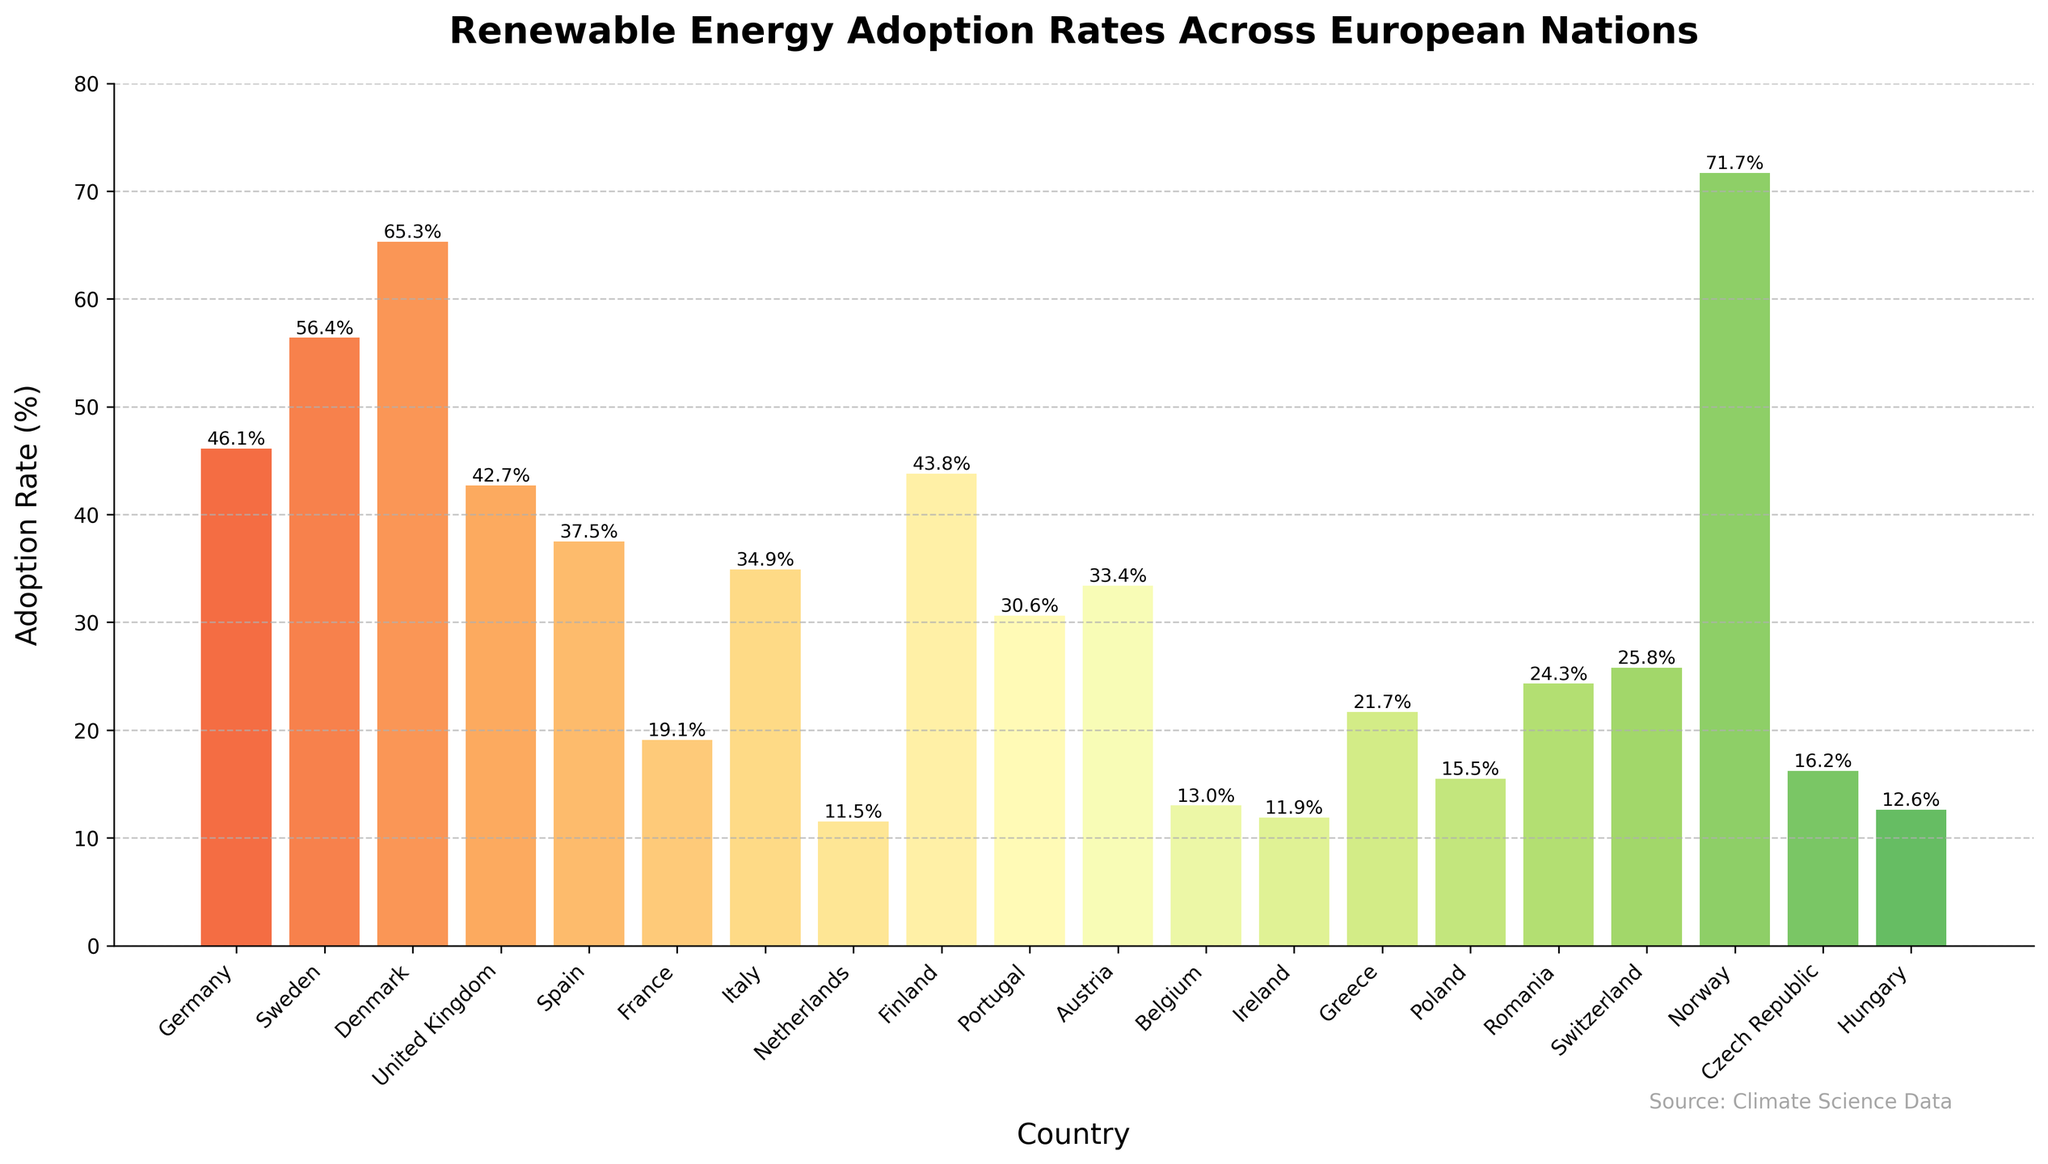Which country has the highest renewable energy adoption rate? By observing the height of the bars in the bar chart, we can identify that the tallest bar represents the country with the highest renewable energy adoption rate. Norway's bar is the tallest, indicating that Norway has the highest adoption rate.
Answer: Norway Which country has the lowest renewable energy adoption rate? By observing the height of the bars in the bar chart, we can identify that the shortest bar represents the country with the lowest renewable energy adoption rate. The Netherlands' bar is the shortest, indicating that the Netherlands has the lowest adoption rate.
Answer: Netherlands How many countries have a renewable energy adoption rate greater than 40%? By examining the bars that extend above the 40% mark on the y-axis, we can count the number of countries with a renewable energy adoption rate greater than 40%. These countries are Germany, Sweden, Denmark, the United Kingdom, Finland, and Norway.
Answer: 6 What is the average renewable energy adoption rate for Germany, the United Kingdom, and France? To compute the average, sum the adoption rates of the three countries (Germany: 46.1%, United Kingdom: 42.7%, France: 19.1%) and then divide by 3. (46.1 + 42.7 + 19.1) / 3 = 107.9 / 3
Answer: 36.0 Which country has a renewable energy adoption rate closest to the average rate of all countries listed? First, we compute the average adoption rate of all countries. Summing all provided values and dividing by the number of countries (20) gives the average. The sum is 533.5%, so the average is 533.5 / 20. Then, we identify the country closest to this average (26.7%). Switzerland at 25.8% is the closest.
Answer: Switzerland Which country has a higher renewable energy adoption rate: Spain or Austria? By comparing the heights of the two relevant bars, we can determine which country has a higher rate. Spain's bar at 37.5% is taller than Austria's at 33.4%, indicating that Spain has a higher adoption rate.
Answer: Spain What is the difference in the renewable energy adoption rates between Sweden and France? Subtract France's adoption rate from Sweden's adoption rate to find the difference. 56.4% - 19.1% = 37.3%
Answer: 37.3% Which country’s bar is visually colored between green and yellow hues, indicating a mid-range adoption rate? By analyzing the colour gradient of the chart, we find that countries with mid-range adoption rates are represented by bars colored between green and yellow. Switzerland, with an adoption rate of 25.8%, fits this description.
Answer: Switzerland How many countries show a renewable energy adoption rate below 20%? We count the bars that do not extend beyond the 20% mark on the y-axis. These countries are France, Belgium, Ireland, Greece, Poland, Czech Republic, and Hungary.
Answer: 7 What is the total renewable energy adoption rate for the countries with rates below 15%? Sum the adoption rates of Netherlands (11.5%), Belgium (13.0%), Ireland (11.9%), Poland (15.5%), and Hungary (12.6%). (11.5 + 13.0 + 11.9 + 15.5 + 12.6) = 64.5%
Answer: 64.5% 